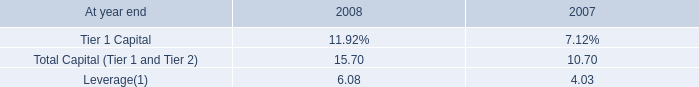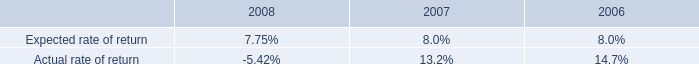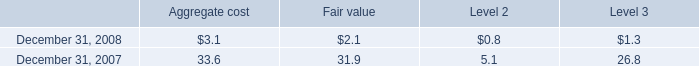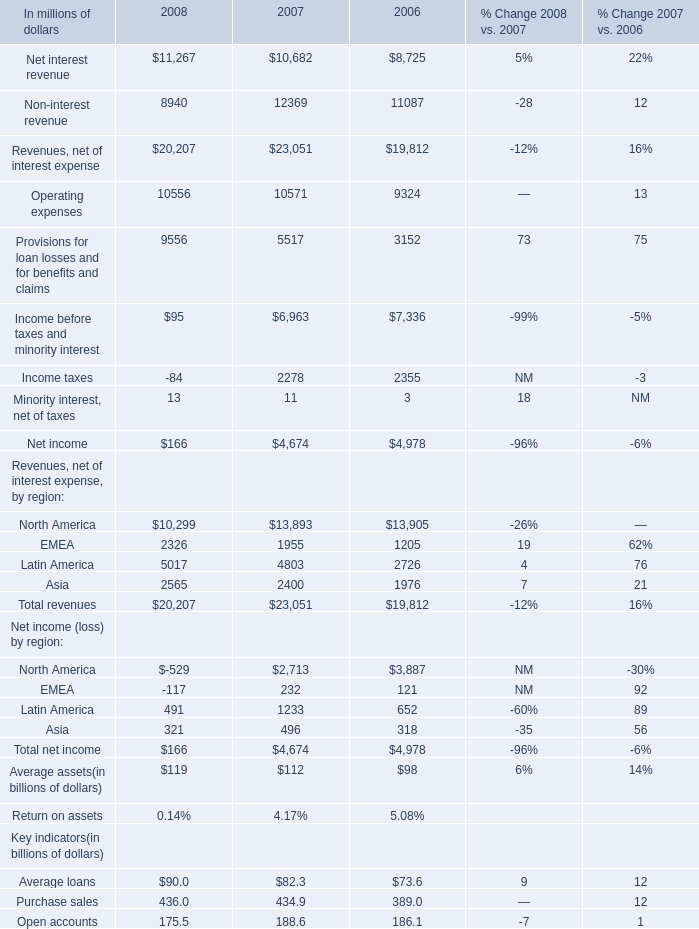what was the percent of the change in the citigroup regulatory capital ratios total capital ( tier 1 and tier 2 ) from 2007 to 2008 
Computations: ((15.70 - 10.70) / 10.70)
Answer: 0.46729. 